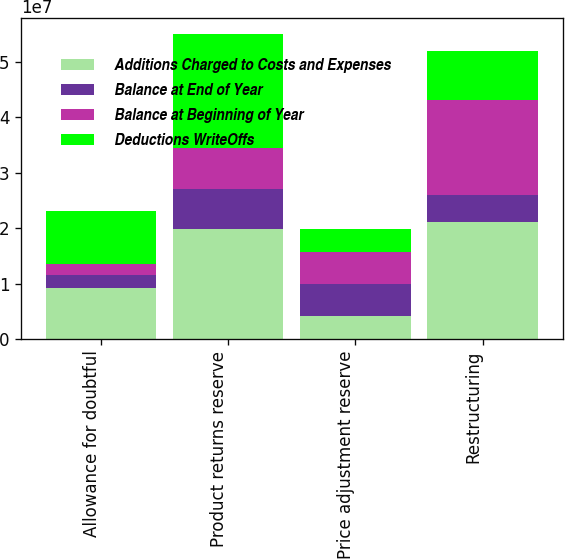<chart> <loc_0><loc_0><loc_500><loc_500><stacked_bar_chart><ecel><fcel>Allowance for doubtful<fcel>Product returns reserve<fcel>Price adjustment reserve<fcel>Restructuring<nl><fcel>Additions Charged to Costs and Expenses<fcel>9.192e+06<fcel>1.9797e+07<fcel>4.088e+06<fcel>2.1108e+07<nl><fcel>Balance at End of Year<fcel>2.378e+06<fcel>7.3535e+06<fcel>5.854e+06<fcel>4.857e+06<nl><fcel>Balance at Beginning of Year<fcel>1.916e+06<fcel>7.3535e+06<fcel>5.751e+06<fcel>1.7112e+07<nl><fcel>Deductions WriteOffs<fcel>9.654e+06<fcel>2.059e+07<fcel>4.191e+06<fcel>8.853e+06<nl></chart> 